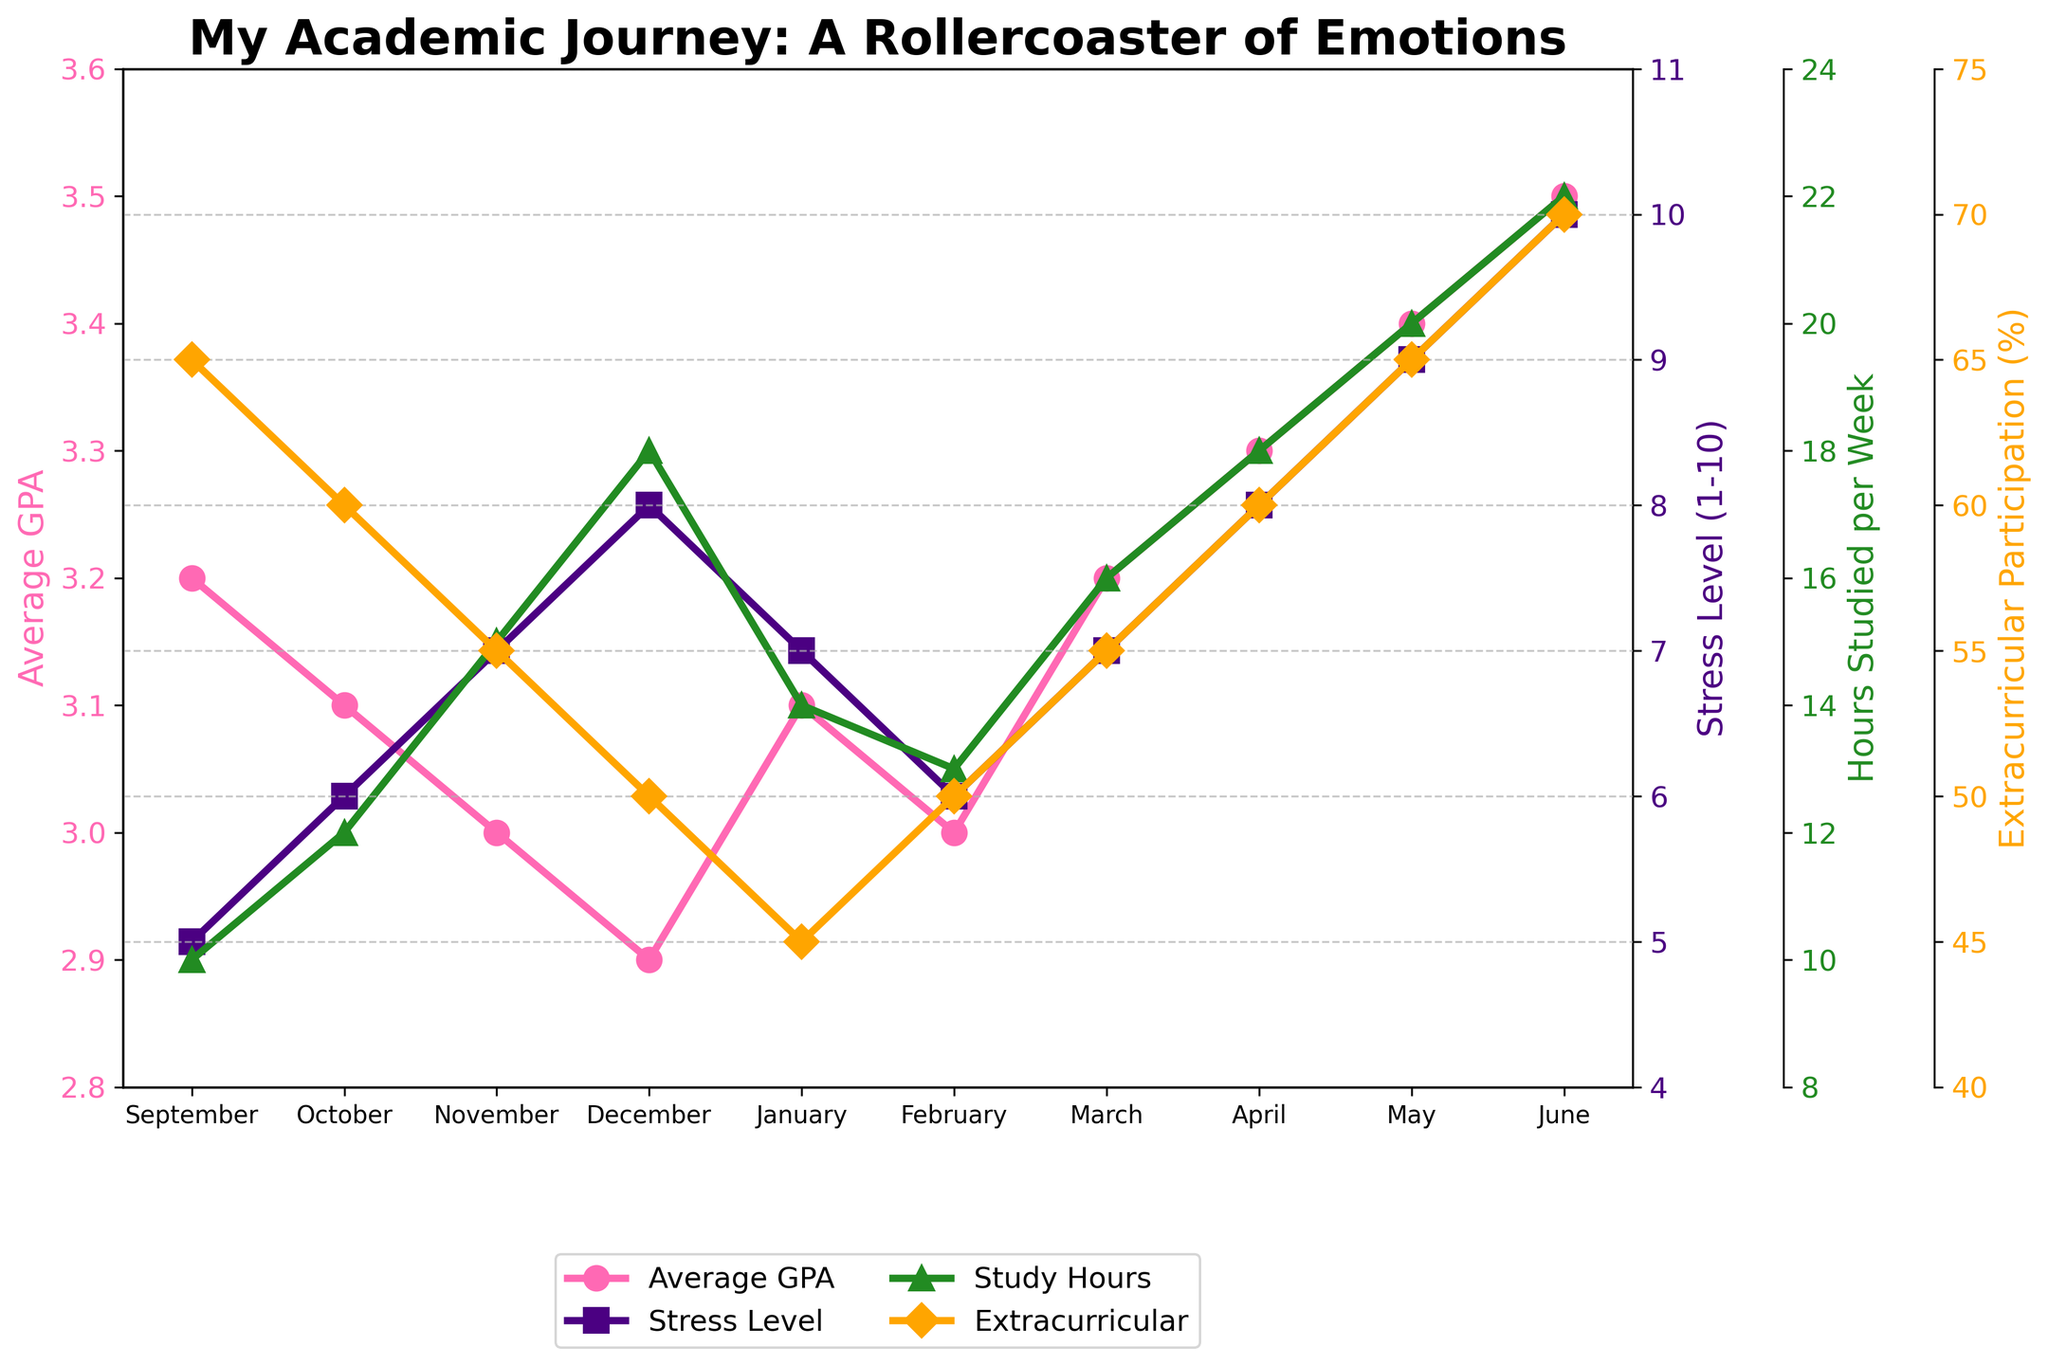What happens to the stress level of students from September to June? The stress level starts at 5 in September and progressively increases each month, reaching a peak at 10 in June.
Answer: The stress level increases How does the average GPA trend compare to the stress level trend throughout the school year? While the stress level steadily increases from 5 to 10, the average GPA shows minor fluctuations, first decreasing until December, then gradually increasing to 3.5 in June.
Answer: Stress level increases, GPA fluctuates then increases During which month do students study the most hours per week? By observing the line plot, the peak of the "Hours Studied per Week" curve occurs in June, with students studying 22 hours per week.
Answer: June How does the level of extracurricular participation change throughout the year? The level of extracurricular participation starts at 65% in September, decreases to a low of 45% by January, then gradually climbs back up to 70% in June.
Answer: Decreases until January, then increases Is there a month where both the average GPA and stress level are increasing? When splitting the observation into two parts, from January to June, both the average GPA and stress level curves show an increasing trend.
Answer: January to June When comparing November and March, in which month did students spend more hours studying per week? Looking at the "Hours Studied per Week" line in November, students studied 15 hours, while in March, they studied 16 hours.
Answer: March What's the difference in stress level between April and December? In December, the stress level is 8, and it remains the same in April. The difference is 0, meaning no change in stress level between these months.
Answer: 0 Which months saw the lowest and highest levels of extracurricular participation, and what were those levels? The lowest extracurricular participation level occurred in January with 45%, while the highest was in June with 70%.
Answer: January (45%) and June (70%) How much did the average GPA increase from its lowest point to its highest point? The lowest point for average GPA is 2.9 in December, and the highest point is 3.5 in June. The increase is 3.5 - 2.9 = 0.6.
Answer: 0.6 